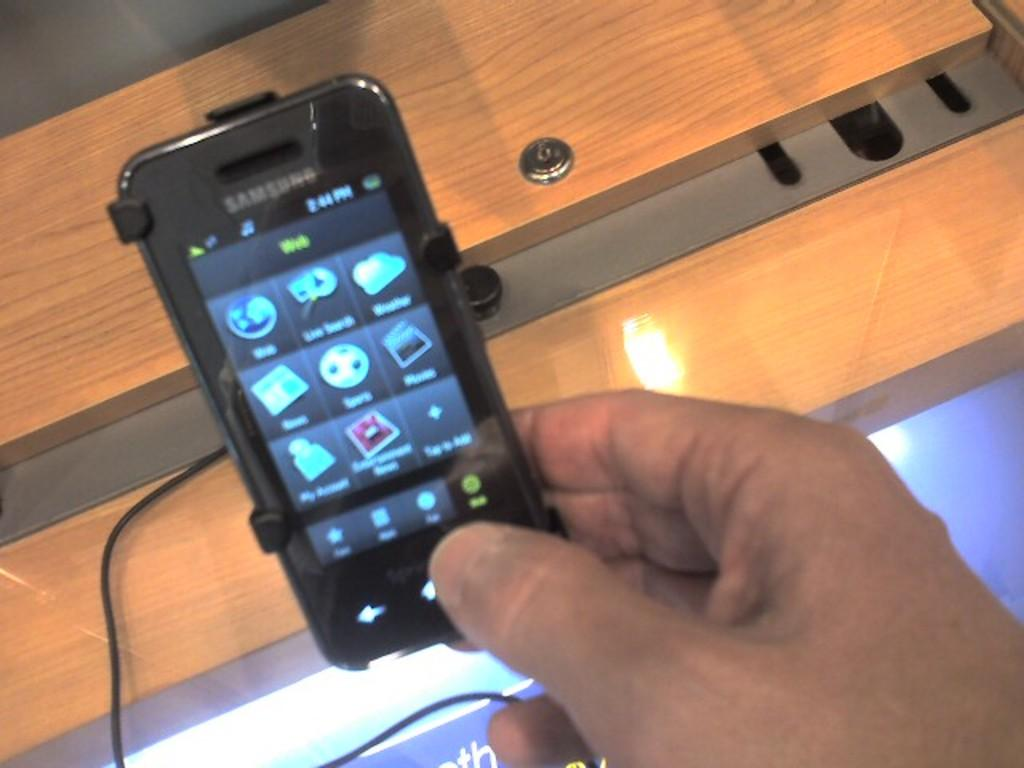Provide a one-sentence caption for the provided image. A man is holding a Samsung smartphone that is plugged into the display counter of a store. 